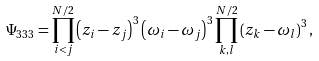Convert formula to latex. <formula><loc_0><loc_0><loc_500><loc_500>\Psi _ { 3 3 3 } = \prod _ { i < j } ^ { N / 2 } \left ( z _ { i } - z _ { j } \right ) ^ { 3 } \left ( \omega _ { i } - \omega _ { j } \right ) ^ { 3 } \prod _ { k , l } ^ { N / 2 } \left ( z _ { k } - \omega _ { l } \right ) ^ { 3 } ,</formula> 